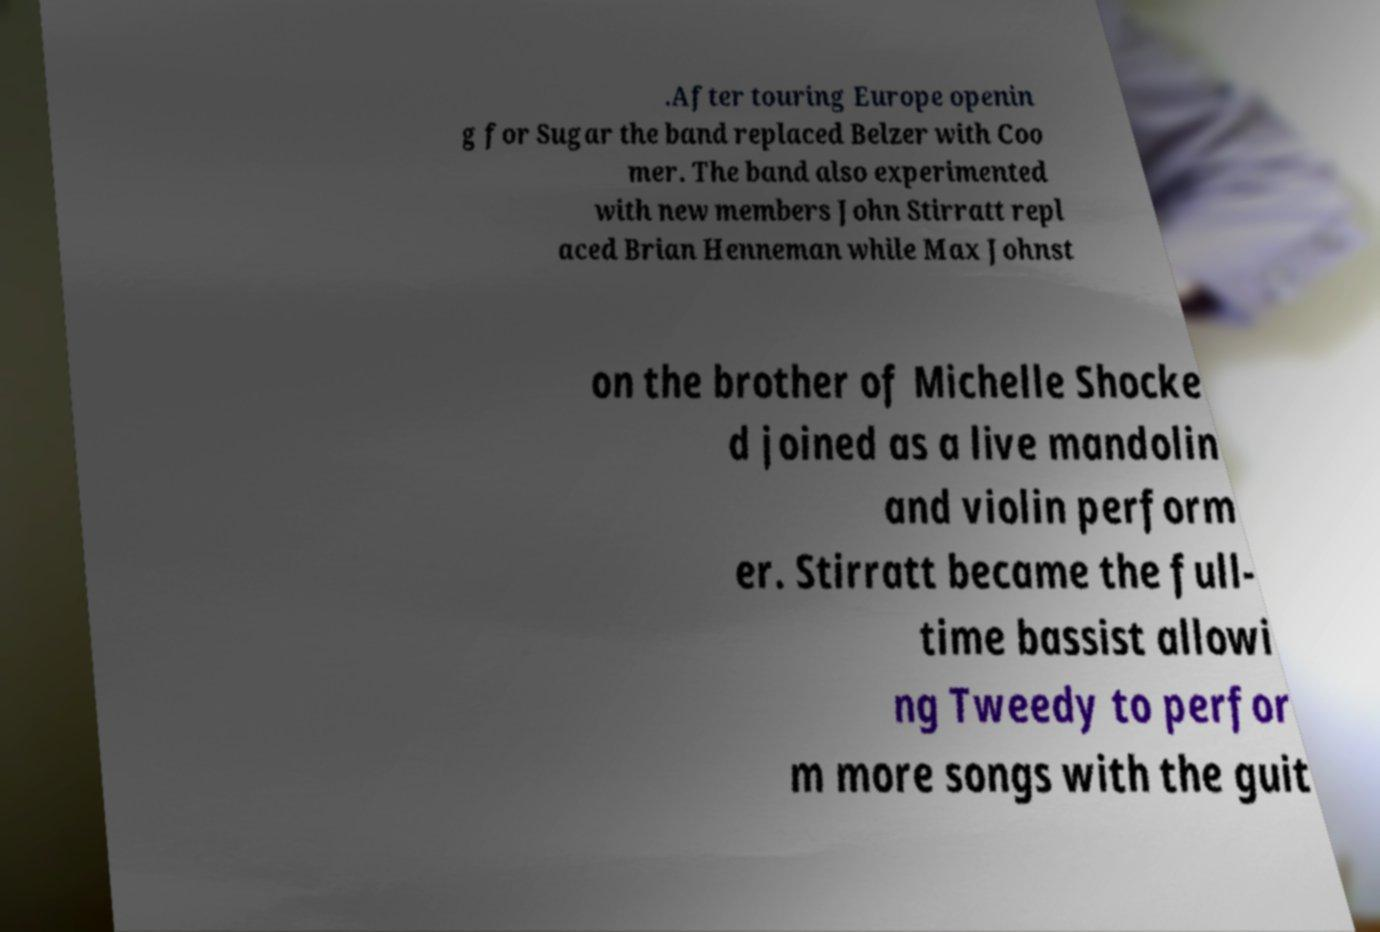Could you extract and type out the text from this image? .After touring Europe openin g for Sugar the band replaced Belzer with Coo mer. The band also experimented with new members John Stirratt repl aced Brian Henneman while Max Johnst on the brother of Michelle Shocke d joined as a live mandolin and violin perform er. Stirratt became the full- time bassist allowi ng Tweedy to perfor m more songs with the guit 